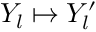<formula> <loc_0><loc_0><loc_500><loc_500>Y _ { l } \mapsto Y _ { l } ^ { \prime }</formula> 